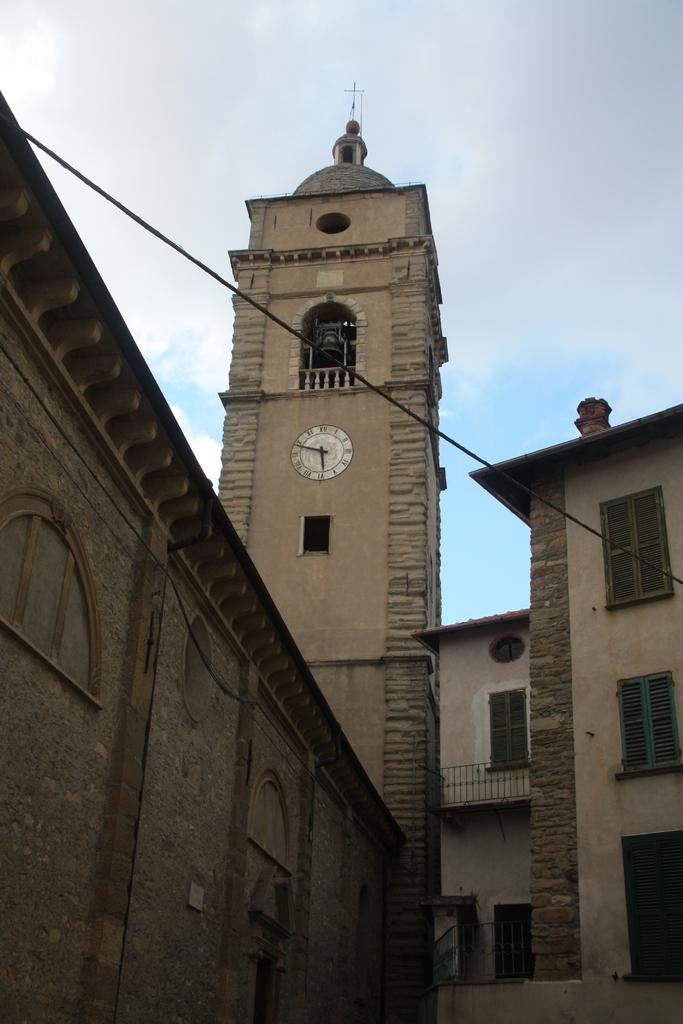What type of structures can be seen in the image? There are buildings in the image. What is the prominent feature in the front of the image? There is a clock tower in the front of the image. What is located in the center of the image? There is a wire in the center of the image. What can be seen in the background of the image? There are clouds and the sky visible in the background of the image. Can you tell me how many loaves of bread are on the tray in the image? There is no tray or loaves of bread present in the image. What type of servant is attending to the clock tower in the image? There is no servant present in the image, and the clock tower is not being attended to. 